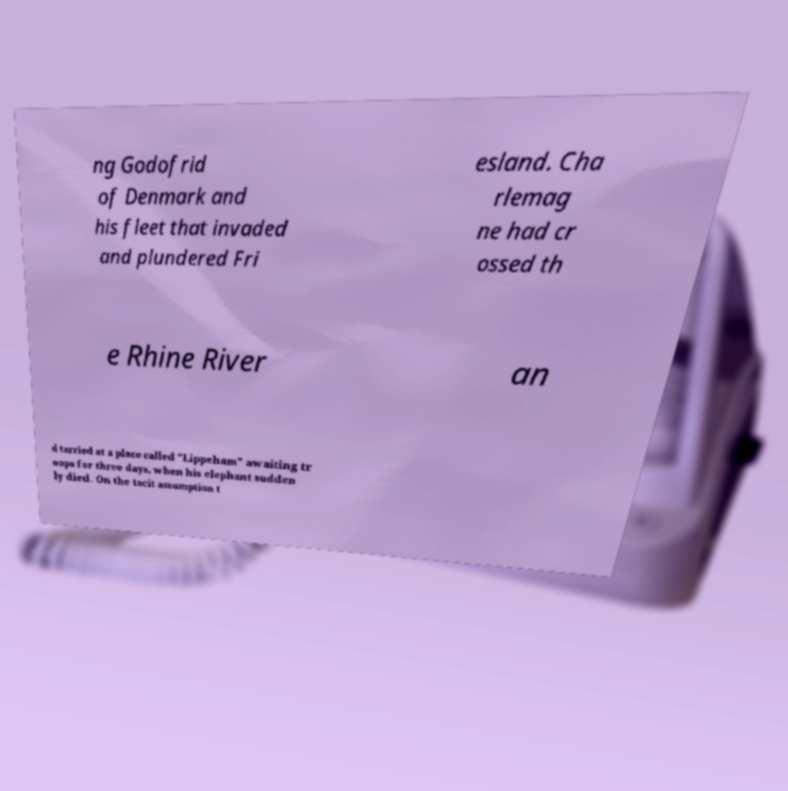Can you accurately transcribe the text from the provided image for me? ng Godofrid of Denmark and his fleet that invaded and plundered Fri esland. Cha rlemag ne had cr ossed th e Rhine River an d tarried at a place called "Lippeham" awaiting tr oops for three days, when his elephant sudden ly died. On the tacit assumption t 